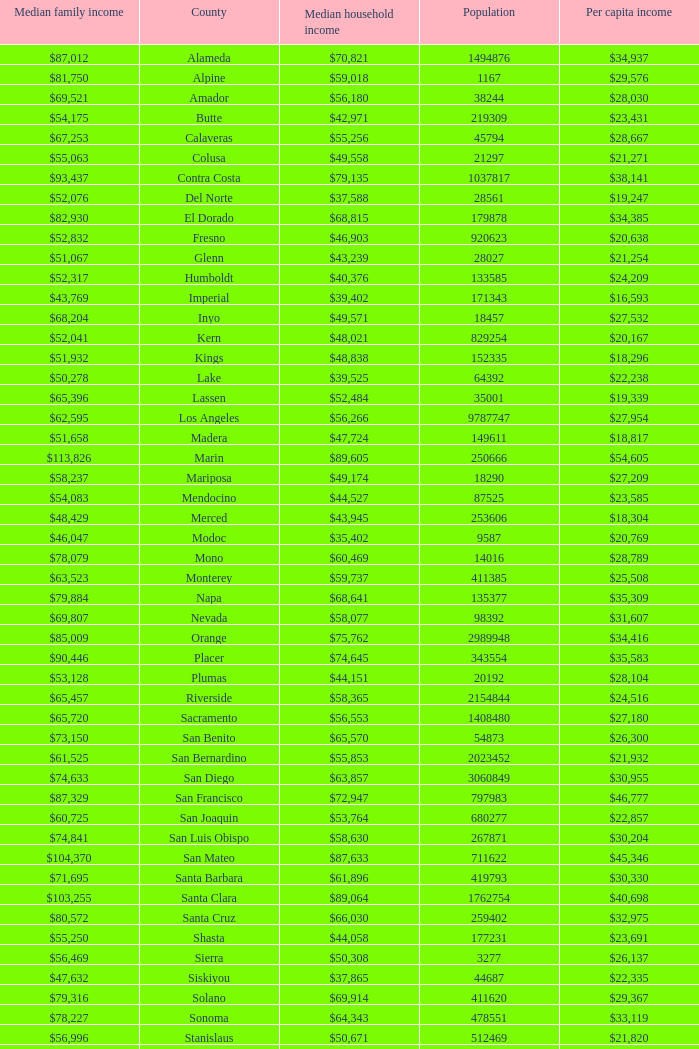What is the median household income of butte? $42,971. 